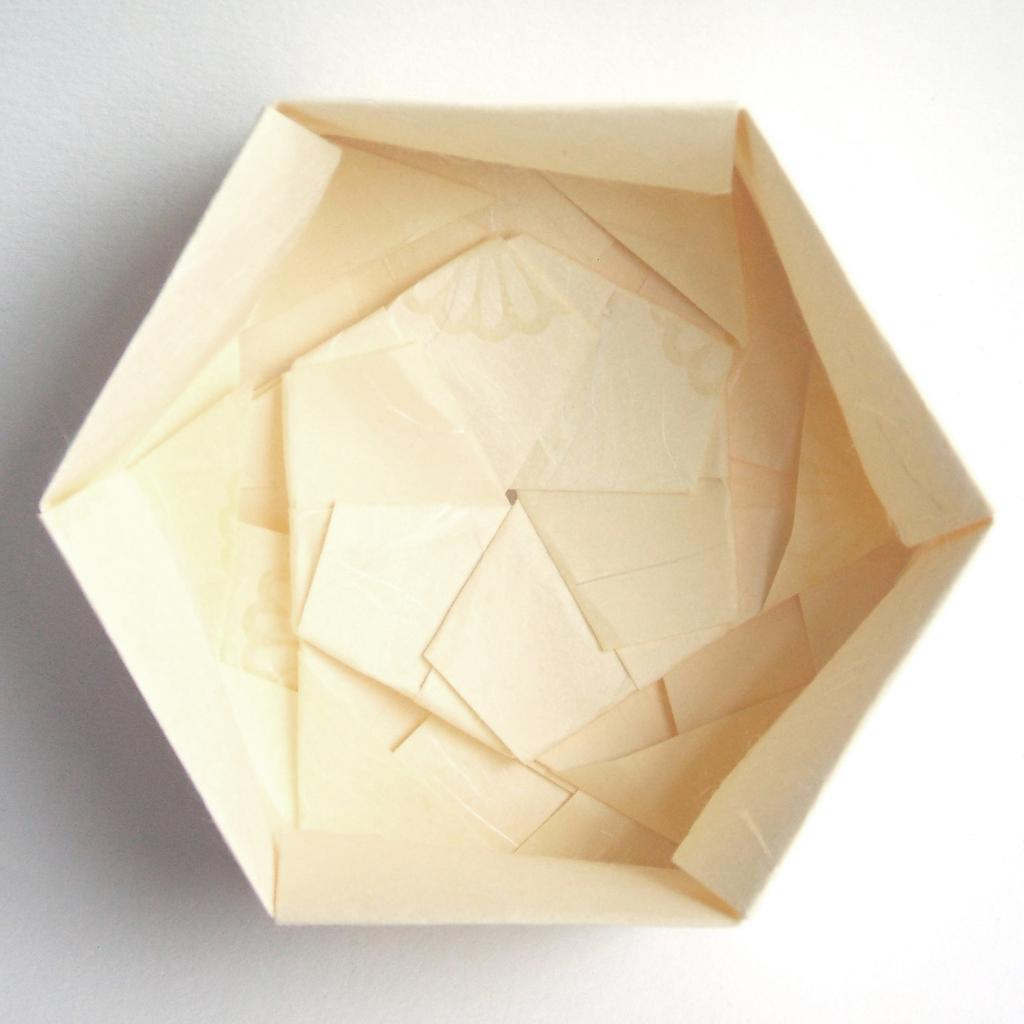What is the main object in the image? There is a box in the image. What material is the box made of? The box is made with paper. On what surface is the box placed? The box is on a white surface. How does the box provide comfort to the person in the image? There is no person present in the image, and the box is not shown providing comfort. 